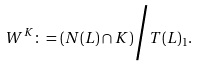Convert formula to latex. <formula><loc_0><loc_0><loc_500><loc_500>W ^ { K } \colon = \left ( N ( L ) \cap K \right ) \Big / T ( L ) _ { 1 } .</formula> 